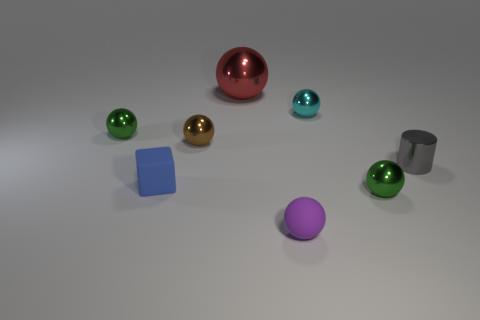Subtract all tiny matte balls. How many balls are left? 5 Subtract all purple spheres. How many spheres are left? 5 Subtract all red balls. Subtract all red blocks. How many balls are left? 5 Add 1 green matte things. How many objects exist? 9 Subtract all cylinders. How many objects are left? 7 Add 6 tiny rubber cubes. How many tiny rubber cubes are left? 7 Add 1 tiny cyan metallic balls. How many tiny cyan metallic balls exist? 2 Subtract 2 green spheres. How many objects are left? 6 Subtract all yellow spheres. Subtract all blocks. How many objects are left? 7 